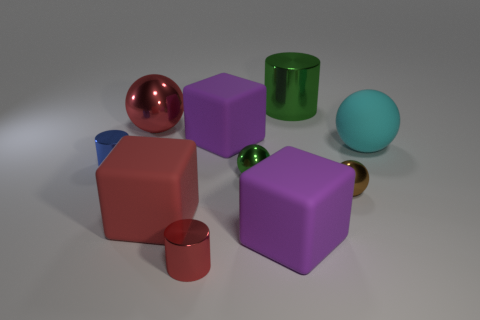Is there any other thing that has the same material as the brown thing? Yes, the spherical object on the left, which appears to have a reflective surface similar to that of the brown object, is likely made of a similar material, possibly a polished metal. 